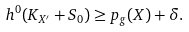<formula> <loc_0><loc_0><loc_500><loc_500>h ^ { 0 } ( K _ { X ^ { \prime } } + S _ { 0 } ) \geq p _ { g } ( X ) + \delta .</formula> 